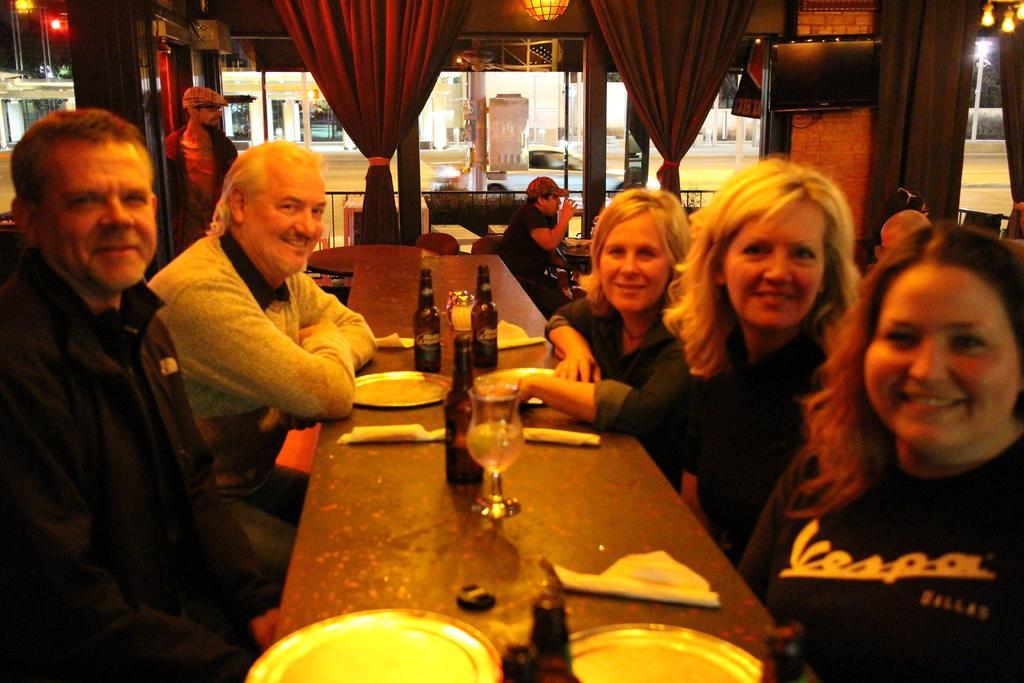How would you summarize this image in a sentence or two? In the image there is a table, on the table there are bottles and plates, around the table there are few people sitting and behind them there are curtains, windows, lights and behind the windows there is a garden. 